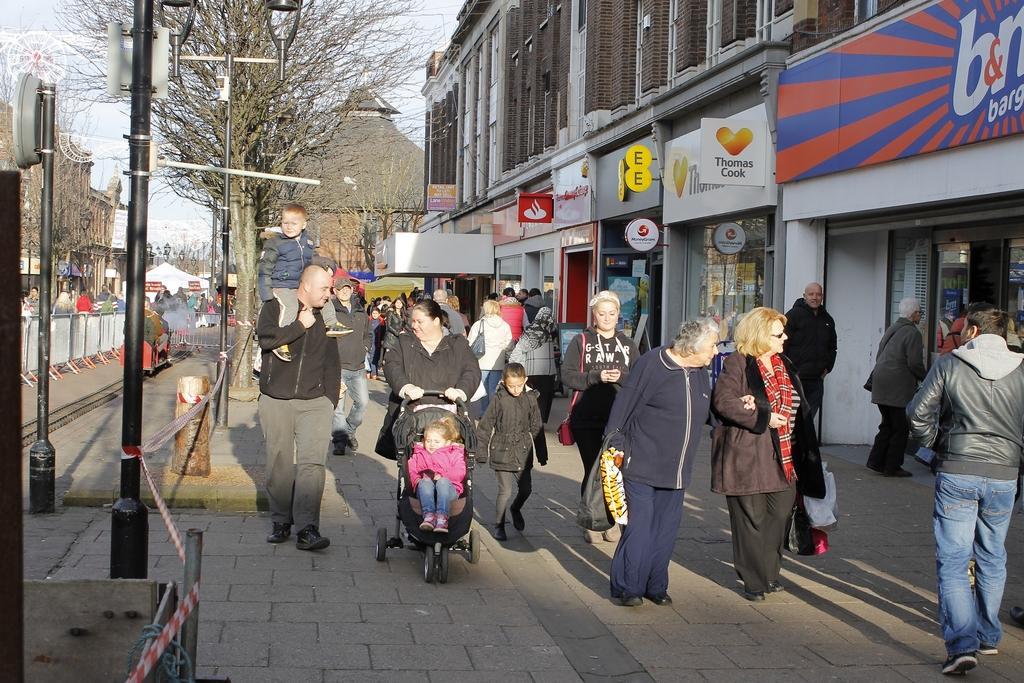Could you give a brief overview of what you see in this image? In the picture we can see many people are walking on the path and beside them, we can see the buildings with shops and on the other side, we can see the poles, trees and far away from it we can see the buildings and a part of the sky. 